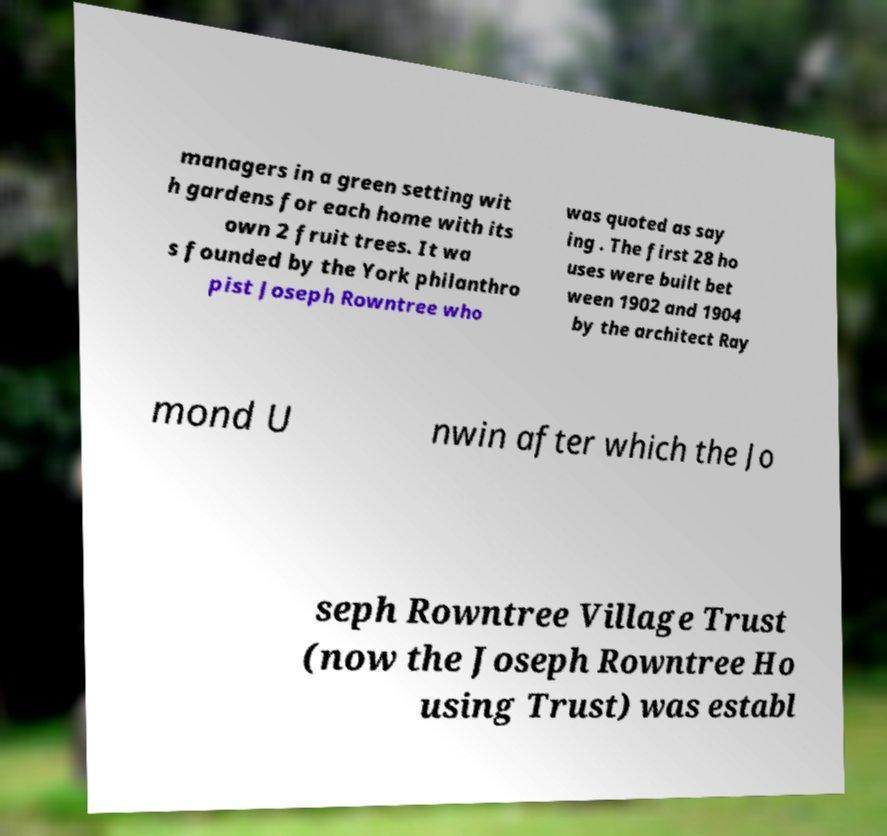What messages or text are displayed in this image? I need them in a readable, typed format. managers in a green setting wit h gardens for each home with its own 2 fruit trees. It wa s founded by the York philanthro pist Joseph Rowntree who was quoted as say ing . The first 28 ho uses were built bet ween 1902 and 1904 by the architect Ray mond U nwin after which the Jo seph Rowntree Village Trust (now the Joseph Rowntree Ho using Trust) was establ 